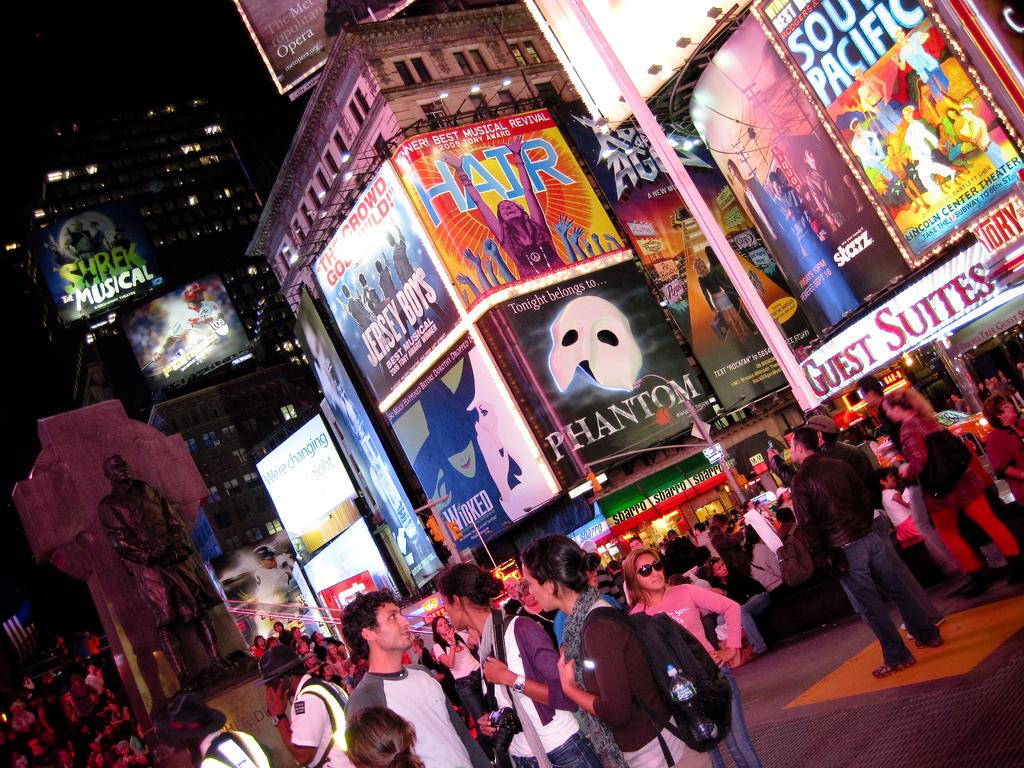What are the people in the image doing? The people in the image are standing on the road. What can be seen in the image besides the people? There is a statue of a person in the image. Where is the statue located in relation to the people? The statue is located among the people. What can be seen in the distance in the image? There are buildings visible in the background of the image. What type of cabbage is being used as a hat by the statue in the image? There is no cabbage present in the image, and the statue is not wearing a hat. How does the cub maintain its balance while standing on the statue in the image? There is no cub present in the image, and the statue is not interacting with any animals. 